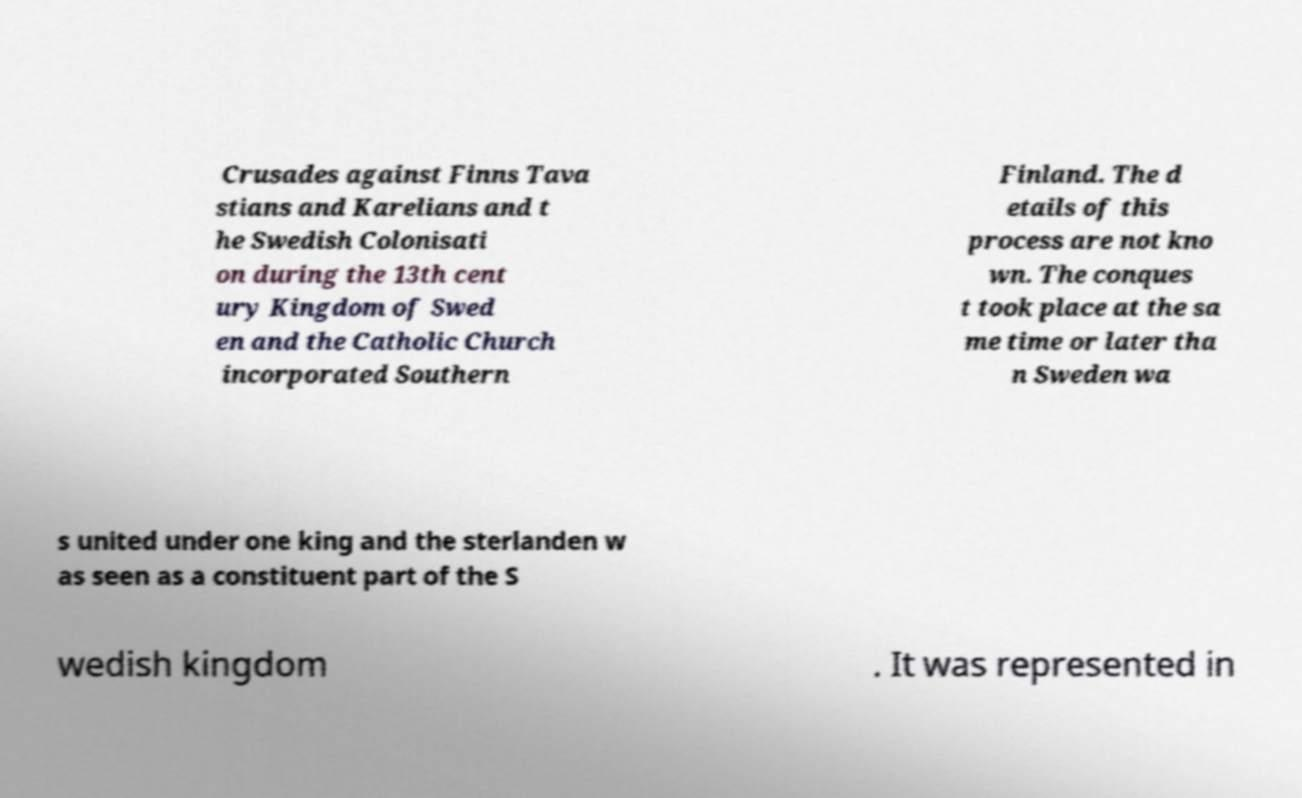Can you accurately transcribe the text from the provided image for me? Crusades against Finns Tava stians and Karelians and t he Swedish Colonisati on during the 13th cent ury Kingdom of Swed en and the Catholic Church incorporated Southern Finland. The d etails of this process are not kno wn. The conques t took place at the sa me time or later tha n Sweden wa s united under one king and the sterlanden w as seen as a constituent part of the S wedish kingdom . It was represented in 